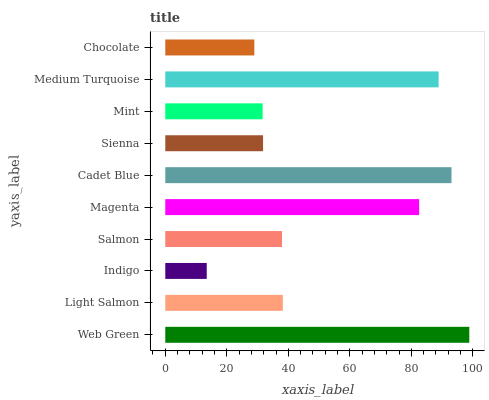Is Indigo the minimum?
Answer yes or no. Yes. Is Web Green the maximum?
Answer yes or no. Yes. Is Light Salmon the minimum?
Answer yes or no. No. Is Light Salmon the maximum?
Answer yes or no. No. Is Web Green greater than Light Salmon?
Answer yes or no. Yes. Is Light Salmon less than Web Green?
Answer yes or no. Yes. Is Light Salmon greater than Web Green?
Answer yes or no. No. Is Web Green less than Light Salmon?
Answer yes or no. No. Is Light Salmon the high median?
Answer yes or no. Yes. Is Salmon the low median?
Answer yes or no. Yes. Is Cadet Blue the high median?
Answer yes or no. No. Is Mint the low median?
Answer yes or no. No. 